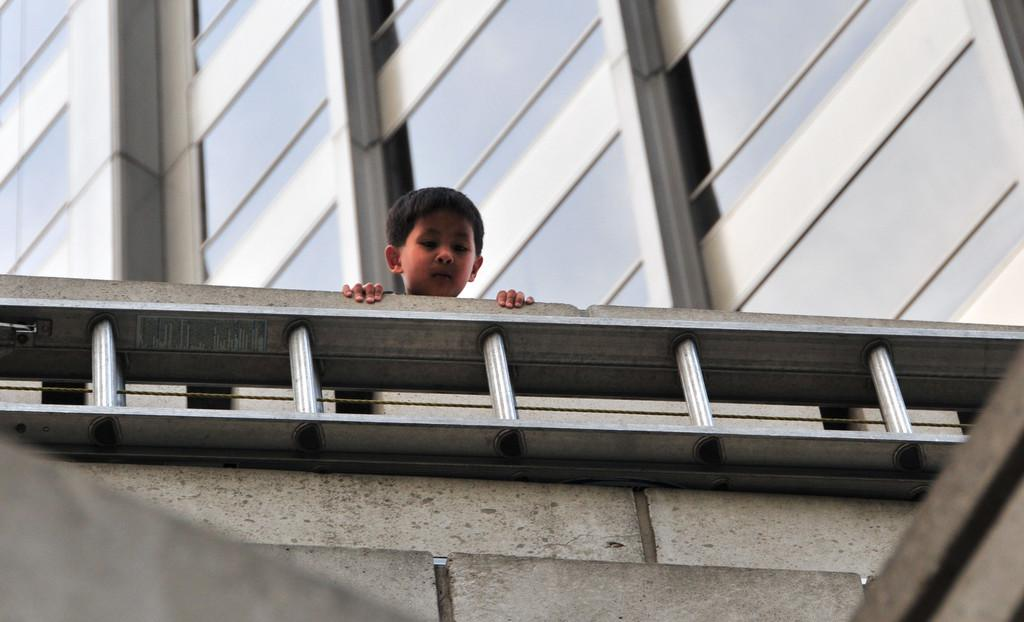What type of structure is visible in the image? There is a wall with a railing in the image. What else can be seen in the image besides the wall with a railing? There is a building in the image. Are there any people present in the image? Yes, there is a boy in the image. What type of skate is the baby using to perform tricks on the beam in the image? There is no baby, skate, or beam present in the image. 